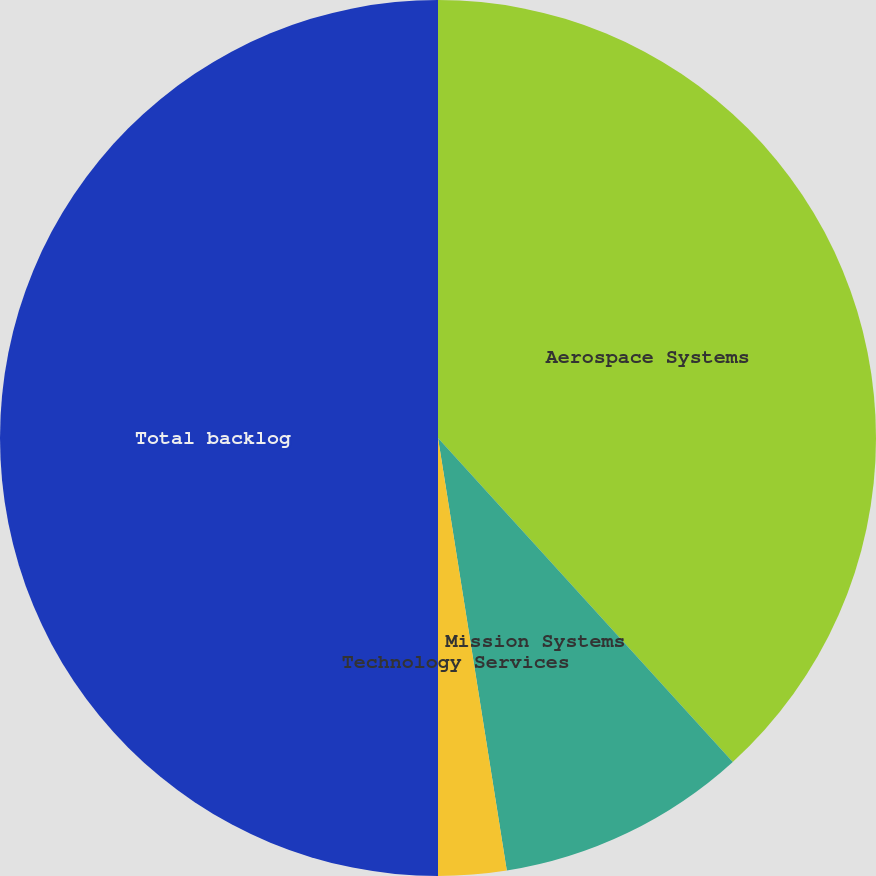Convert chart to OTSL. <chart><loc_0><loc_0><loc_500><loc_500><pie_chart><fcel>Aerospace Systems<fcel>Mission Systems<fcel>Technology Services<fcel>Total backlog<nl><fcel>38.25%<fcel>9.24%<fcel>2.51%<fcel>50.0%<nl></chart> 